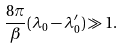<formula> <loc_0><loc_0><loc_500><loc_500>\frac { 8 \pi } { \beta } ( \lambda _ { 0 } - { \lambda } ^ { \prime } _ { 0 } ) \gg 1 .</formula> 